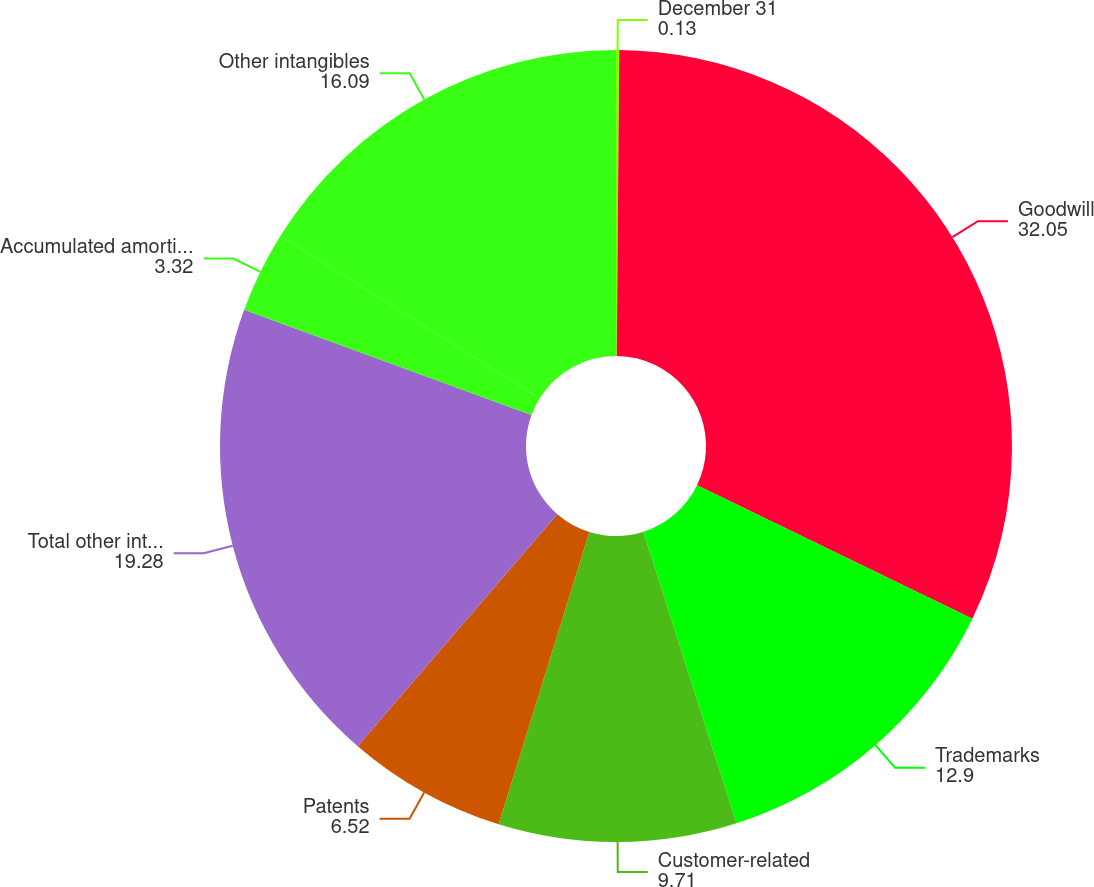Convert chart. <chart><loc_0><loc_0><loc_500><loc_500><pie_chart><fcel>December 31<fcel>Goodwill<fcel>Trademarks<fcel>Customer-related<fcel>Patents<fcel>Total other intangible assets<fcel>Accumulated amortization<fcel>Other intangibles<nl><fcel>0.13%<fcel>32.05%<fcel>12.9%<fcel>9.71%<fcel>6.52%<fcel>19.28%<fcel>3.32%<fcel>16.09%<nl></chart> 